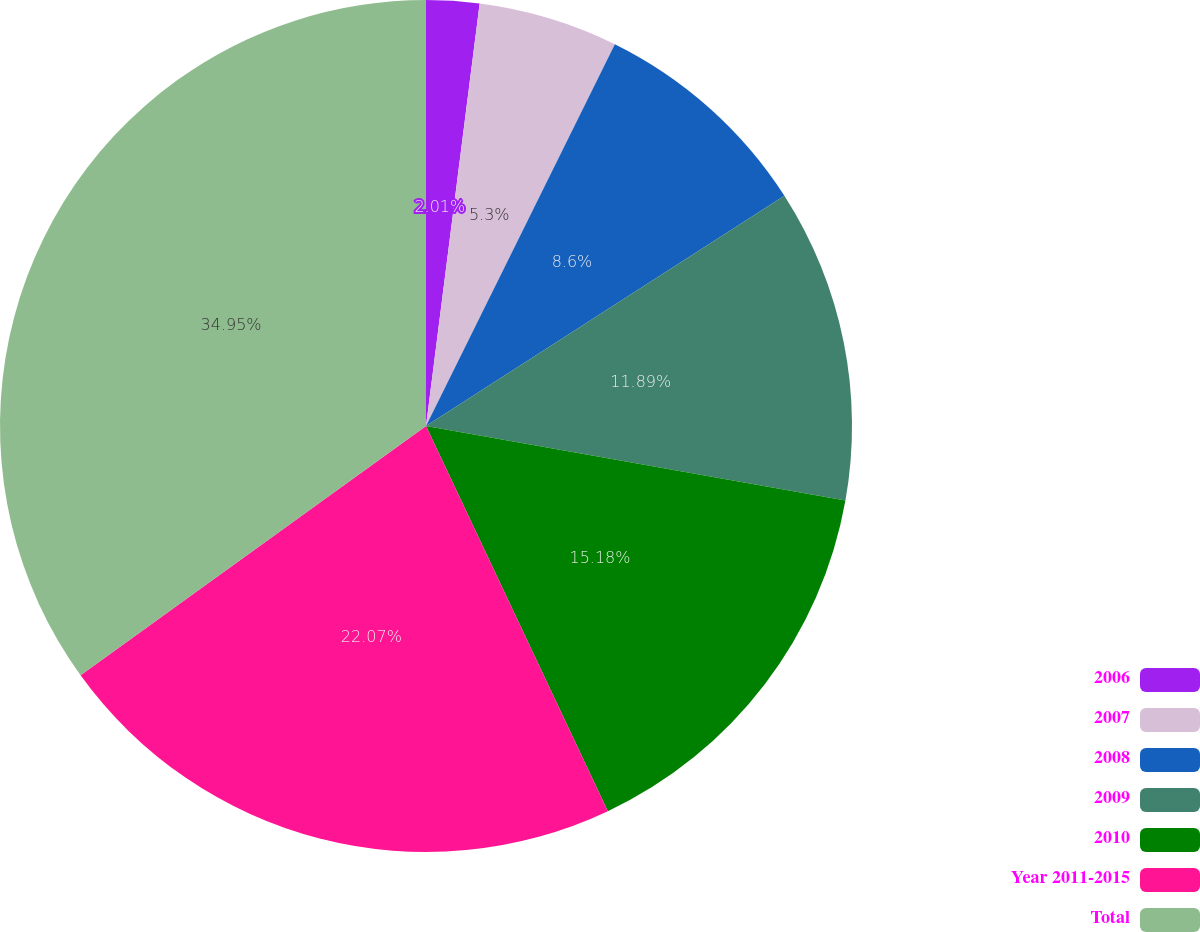Convert chart to OTSL. <chart><loc_0><loc_0><loc_500><loc_500><pie_chart><fcel>2006<fcel>2007<fcel>2008<fcel>2009<fcel>2010<fcel>Year 2011-2015<fcel>Total<nl><fcel>2.01%<fcel>5.3%<fcel>8.6%<fcel>11.89%<fcel>15.18%<fcel>22.07%<fcel>34.95%<nl></chart> 